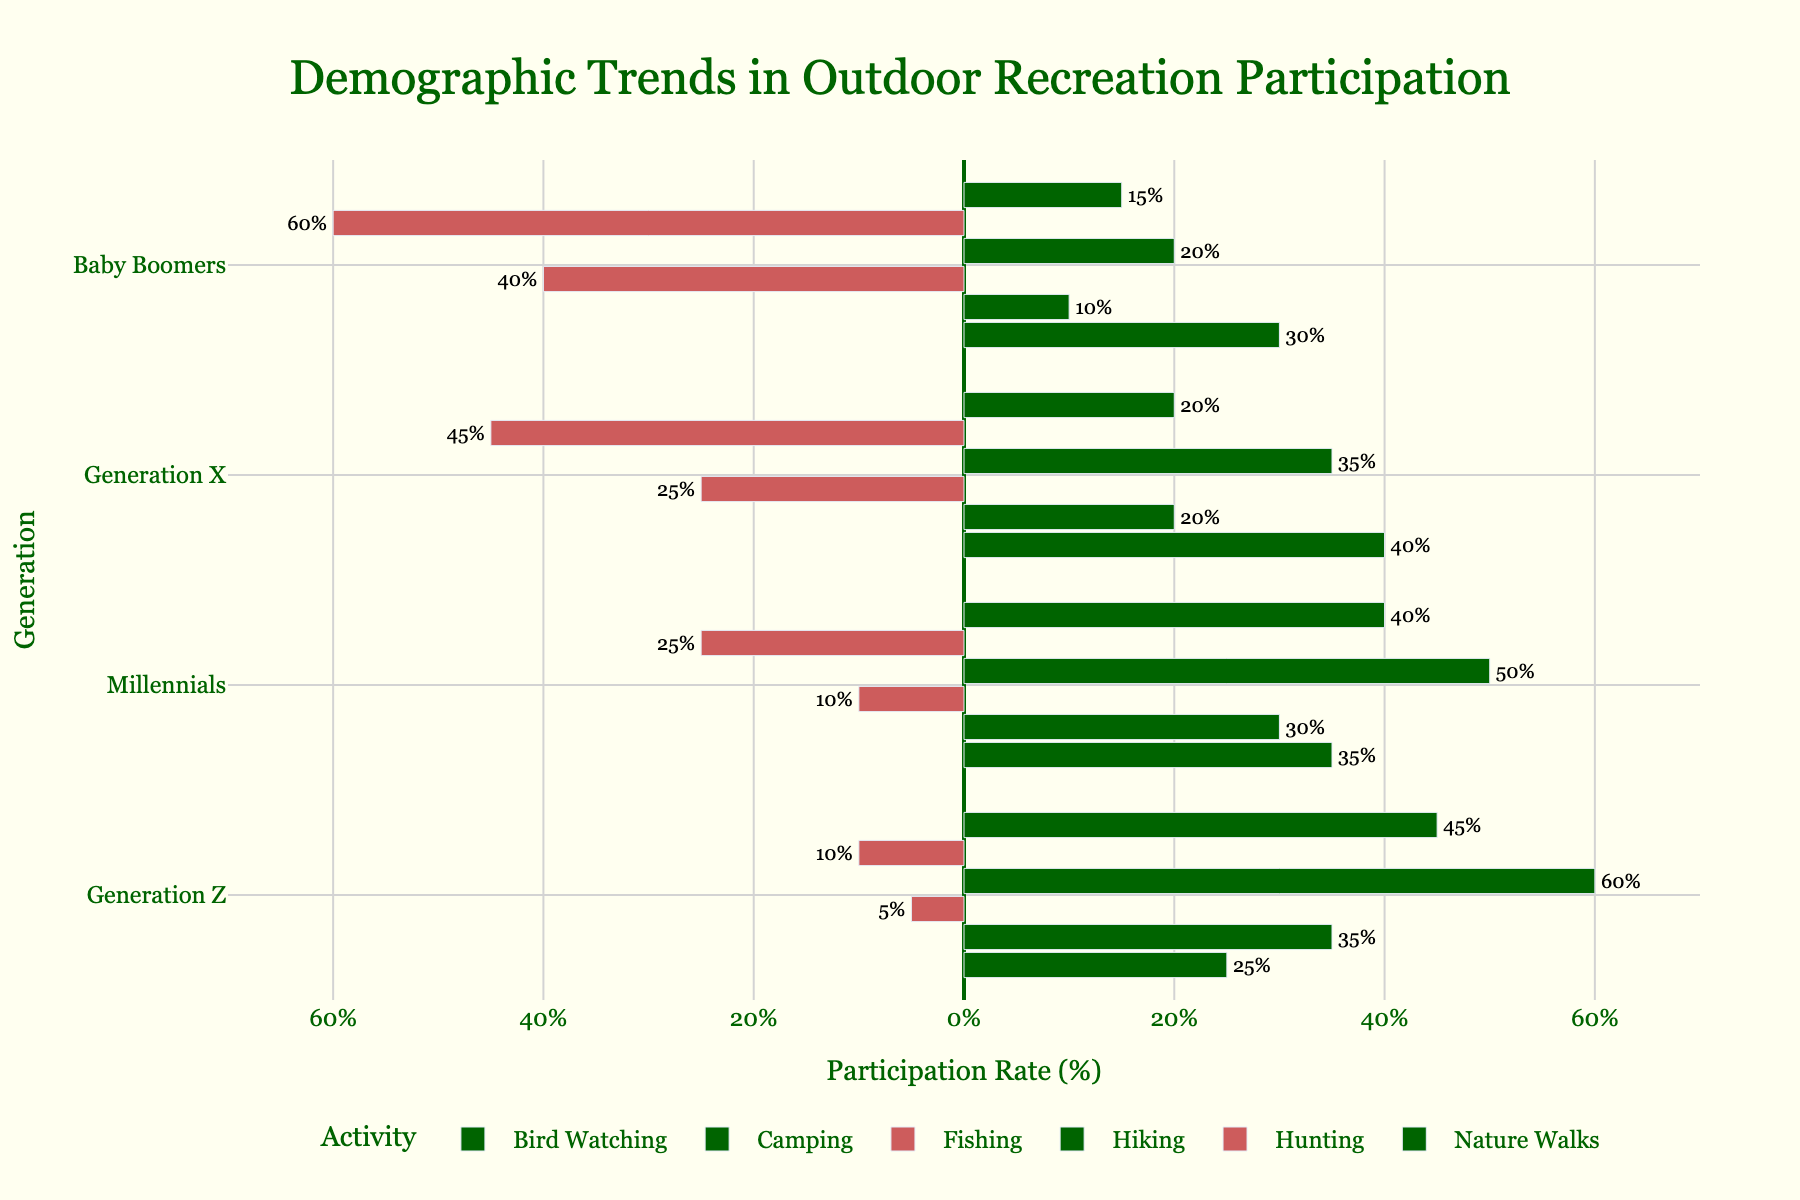Which generation has the highest participation rate in hunting? Identify the bar for hunting and compare the values across generations. Generation Z has the highest rate at -10%.
Answer: Generation Z Which outdoor activity has a positive participation rate across all generations? Scan through each activity's bars to identify any that are positive for Baby Boomers, Generation X, Millennials, and Generation Z. All generations have positive rates for Nature Walks.
Answer: Nature Walks How does the participation rate in hiking change from Baby Boomers to Generation Z? Observe the hiking bars for each generation: Baby Boomers (20), Generation X (35), Millennials (50), and Generation Z (60). Describe the increasing trend.
Answer: Increases Compare the participation rates in fishing between Baby Boomers and Generation Z. Look at the fishing bars and their values: Baby Boomers (-40) and Generation Z (-5). Baby Boomers are much lower.
Answer: Baby Boomers lower Which activity shows the greatest difference in participation rates between Baby Boomers and Generation Z? Calculate the difference for each activity: Hunting (50), Hiking (40), Bird Watching (5), Fishing (35), Camping (25), Nature Walks (30). The greatest is for hunting.
Answer: Hunting What trends do you notice in the colors of the bars for hunting and hiking? The colors for hunting are consistently negative (red/dark) across generations; for hiking, they are positive (green/light). This shows a decline in hunting and a rise in hiking participation.
Answer: Hunting declines, Hiking increases Between Millennials and Generation X, which generation has higher rates in bird watching? Compare the bird watching bars for Millennials (35) and Generation X (40). Generation X has the higher rate.
Answer: Generation X Which generation has the largest increase in participation rate for hiking compared to the previous generation? Compare the increase for hiking between each consecutive generation: Baby Boomers to Generation X (15), Generation X to Millennials (15), Millennials to Generation Z (10). The largest increase is from Baby Boomers to Generation X.
Answer: Baby Boomers to Generation X 